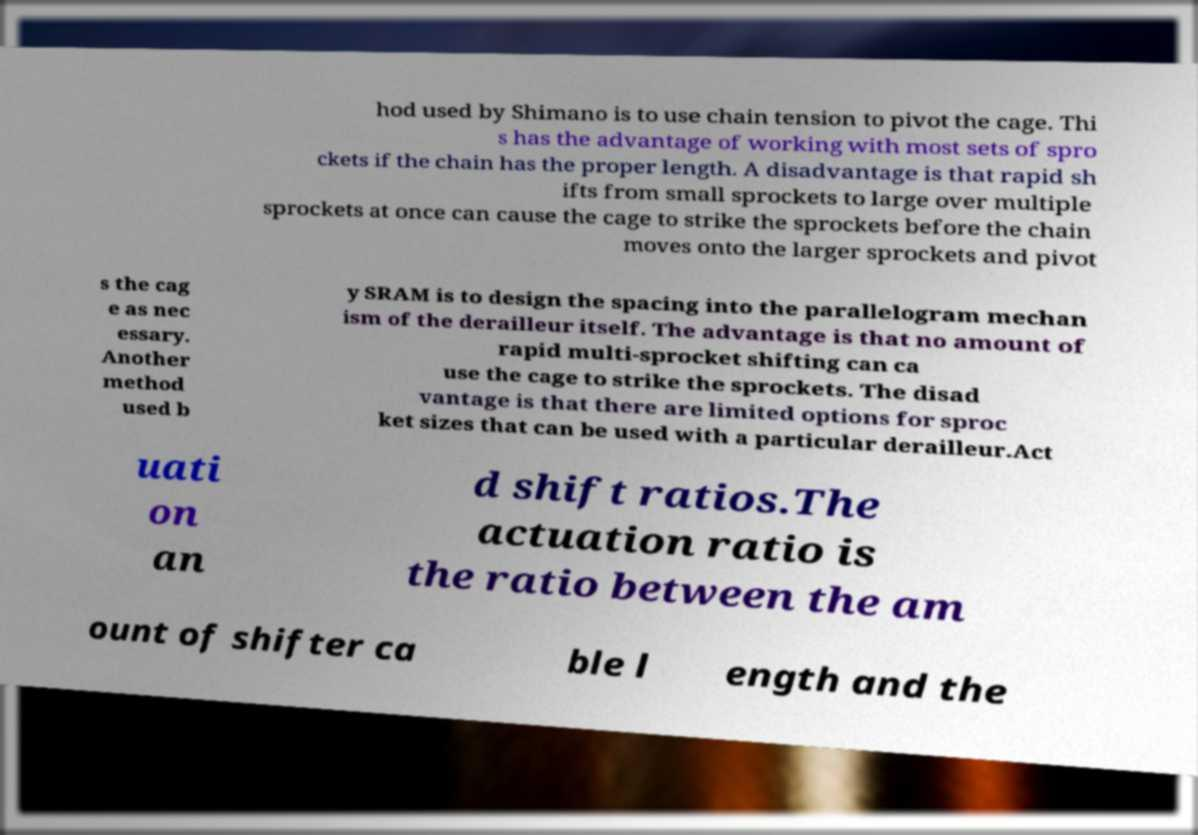Can you accurately transcribe the text from the provided image for me? hod used by Shimano is to use chain tension to pivot the cage. Thi s has the advantage of working with most sets of spro ckets if the chain has the proper length. A disadvantage is that rapid sh ifts from small sprockets to large over multiple sprockets at once can cause the cage to strike the sprockets before the chain moves onto the larger sprockets and pivot s the cag e as nec essary. Another method used b y SRAM is to design the spacing into the parallelogram mechan ism of the derailleur itself. The advantage is that no amount of rapid multi-sprocket shifting can ca use the cage to strike the sprockets. The disad vantage is that there are limited options for sproc ket sizes that can be used with a particular derailleur.Act uati on an d shift ratios.The actuation ratio is the ratio between the am ount of shifter ca ble l ength and the 